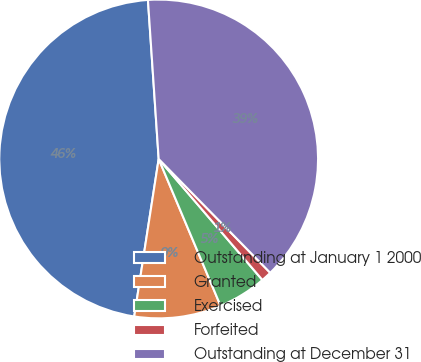Convert chart to OTSL. <chart><loc_0><loc_0><loc_500><loc_500><pie_chart><fcel>Outstanding at January 1 2000<fcel>Granted<fcel>Exercised<fcel>Forfeited<fcel>Outstanding at December 31<nl><fcel>46.47%<fcel>8.8%<fcel>4.93%<fcel>1.06%<fcel>38.73%<nl></chart> 